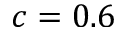<formula> <loc_0><loc_0><loc_500><loc_500>c = 0 . 6</formula> 